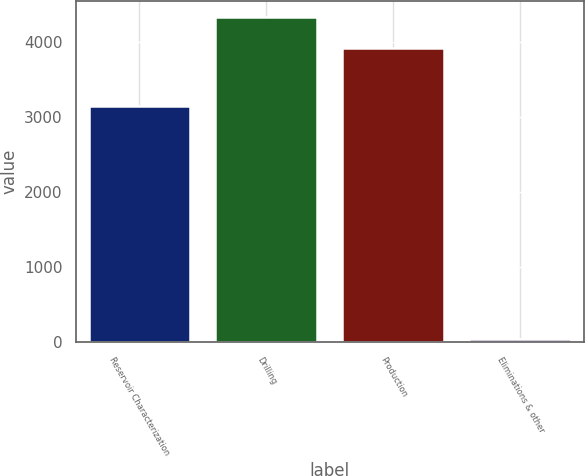Convert chart. <chart><loc_0><loc_0><loc_500><loc_500><bar_chart><fcel>Reservoir Characterization<fcel>Drilling<fcel>Production<fcel>Eliminations & other<nl><fcel>3150<fcel>4334<fcel>3924<fcel>37<nl></chart> 